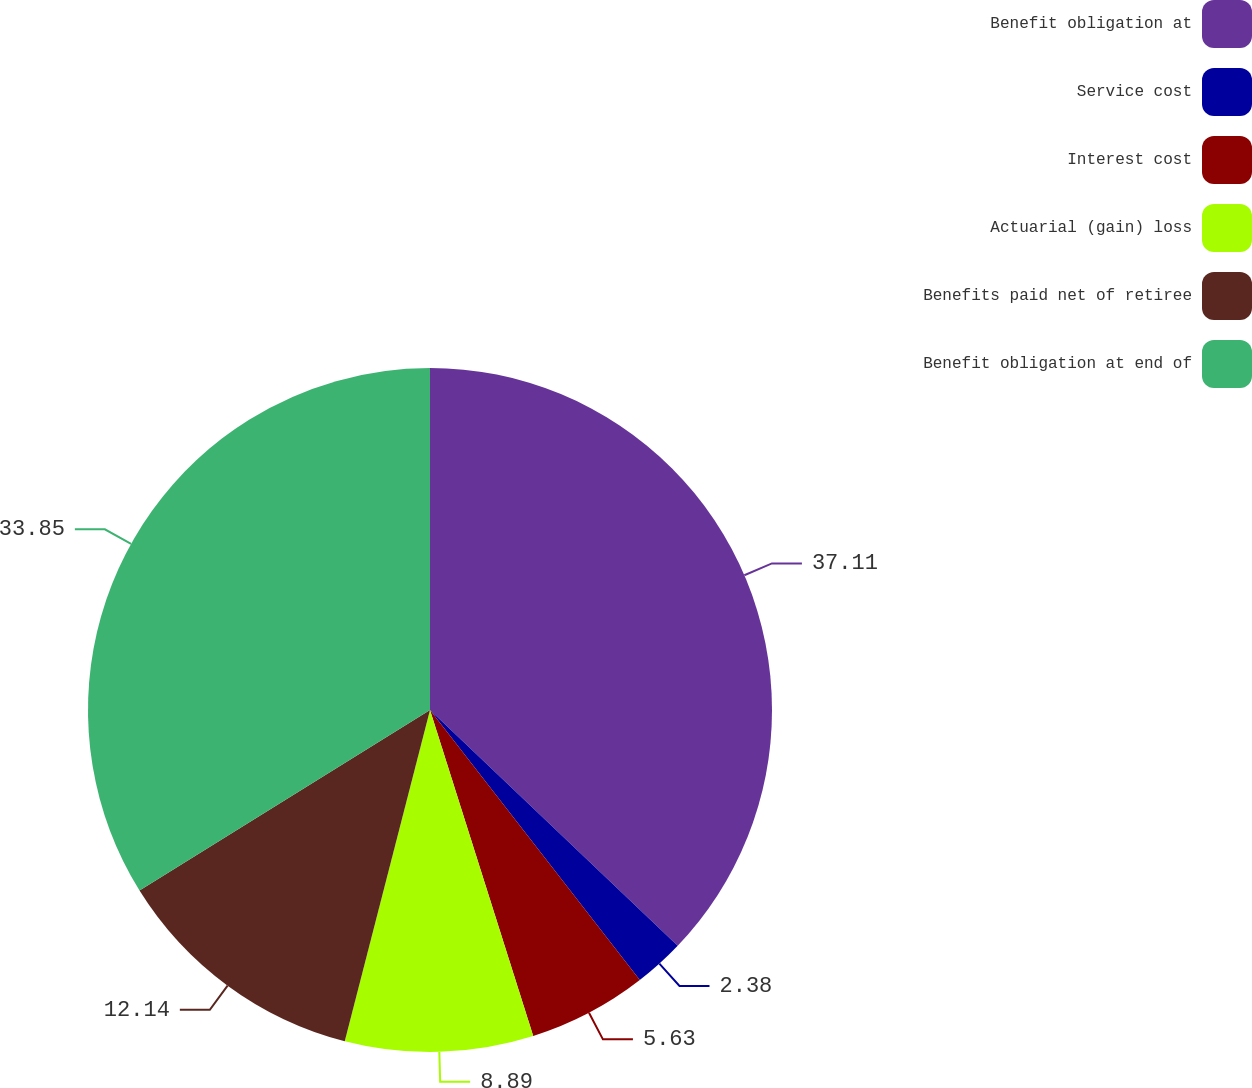Convert chart. <chart><loc_0><loc_0><loc_500><loc_500><pie_chart><fcel>Benefit obligation at<fcel>Service cost<fcel>Interest cost<fcel>Actuarial (gain) loss<fcel>Benefits paid net of retiree<fcel>Benefit obligation at end of<nl><fcel>37.11%<fcel>2.38%<fcel>5.63%<fcel>8.89%<fcel>12.14%<fcel>33.85%<nl></chart> 